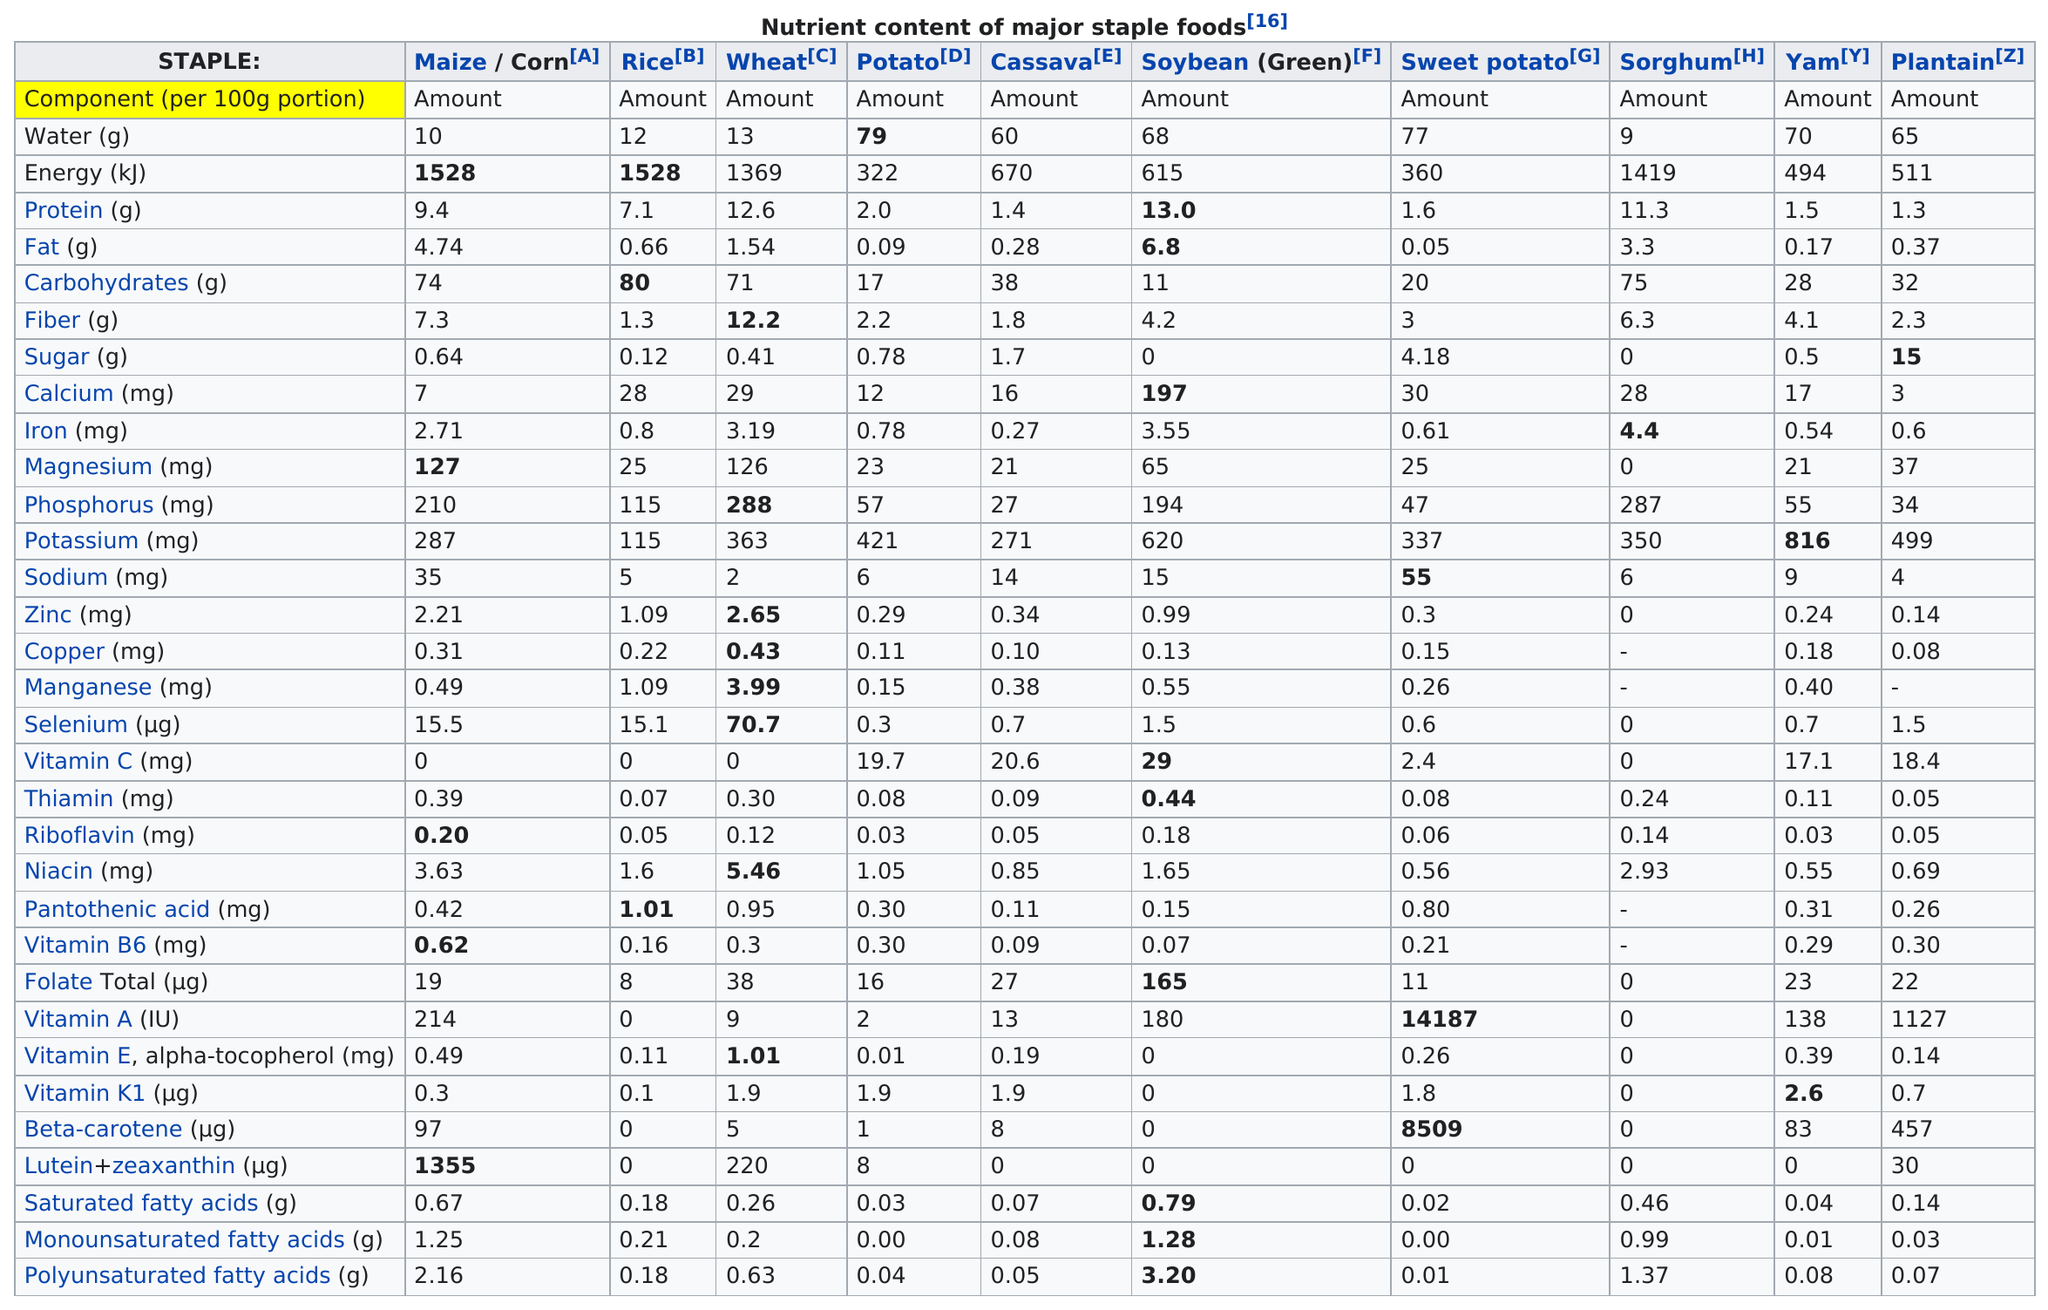Outline some significant characteristics in this image. Staple sweet potatoes have the least amount of fat when compared to other staples. At least how many grams of water do the staple foods have? 9. Out of the staples tested, three of them contained at least 1 milligram of zinc. The staple food that contains the most potassium is yam. Maize, also known as corn, is a food that is high in magnesium. 